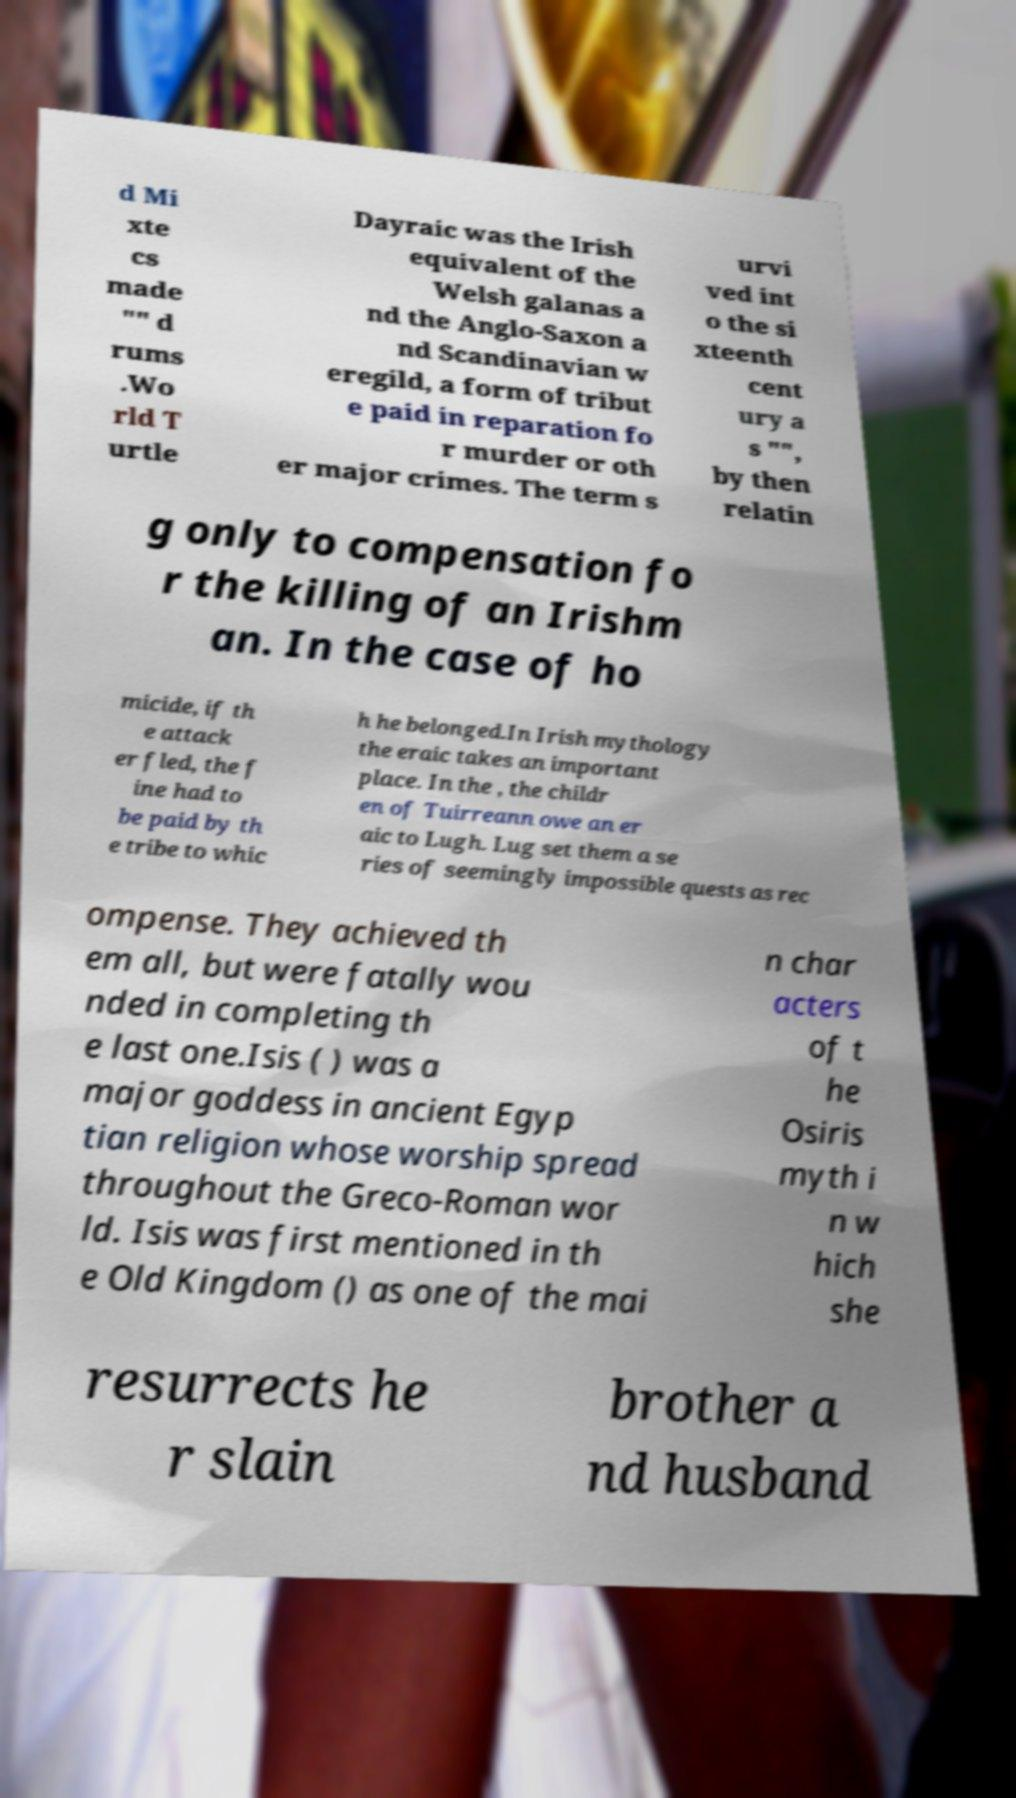Can you accurately transcribe the text from the provided image for me? d Mi xte cs made "" d rums .Wo rld T urtle Dayraic was the Irish equivalent of the Welsh galanas a nd the Anglo-Saxon a nd Scandinavian w eregild, a form of tribut e paid in reparation fo r murder or oth er major crimes. The term s urvi ved int o the si xteenth cent ury a s "", by then relatin g only to compensation fo r the killing of an Irishm an. In the case of ho micide, if th e attack er fled, the f ine had to be paid by th e tribe to whic h he belonged.In Irish mythology the eraic takes an important place. In the , the childr en of Tuirreann owe an er aic to Lugh. Lug set them a se ries of seemingly impossible quests as rec ompense. They achieved th em all, but were fatally wou nded in completing th e last one.Isis ( ) was a major goddess in ancient Egyp tian religion whose worship spread throughout the Greco-Roman wor ld. Isis was first mentioned in th e Old Kingdom () as one of the mai n char acters of t he Osiris myth i n w hich she resurrects he r slain brother a nd husband 